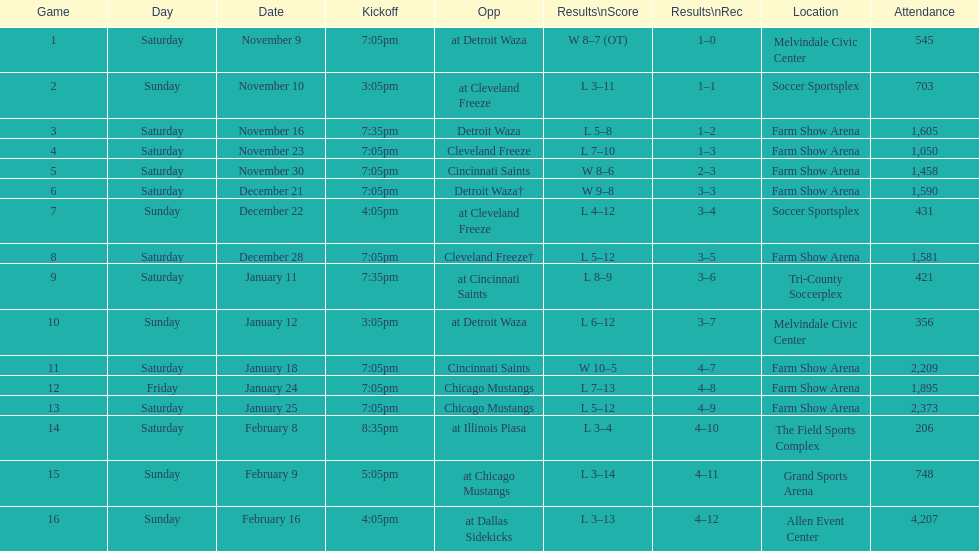In how many matches did the harrisburg heat achieve victory where they scored eight or more goals? 4. 